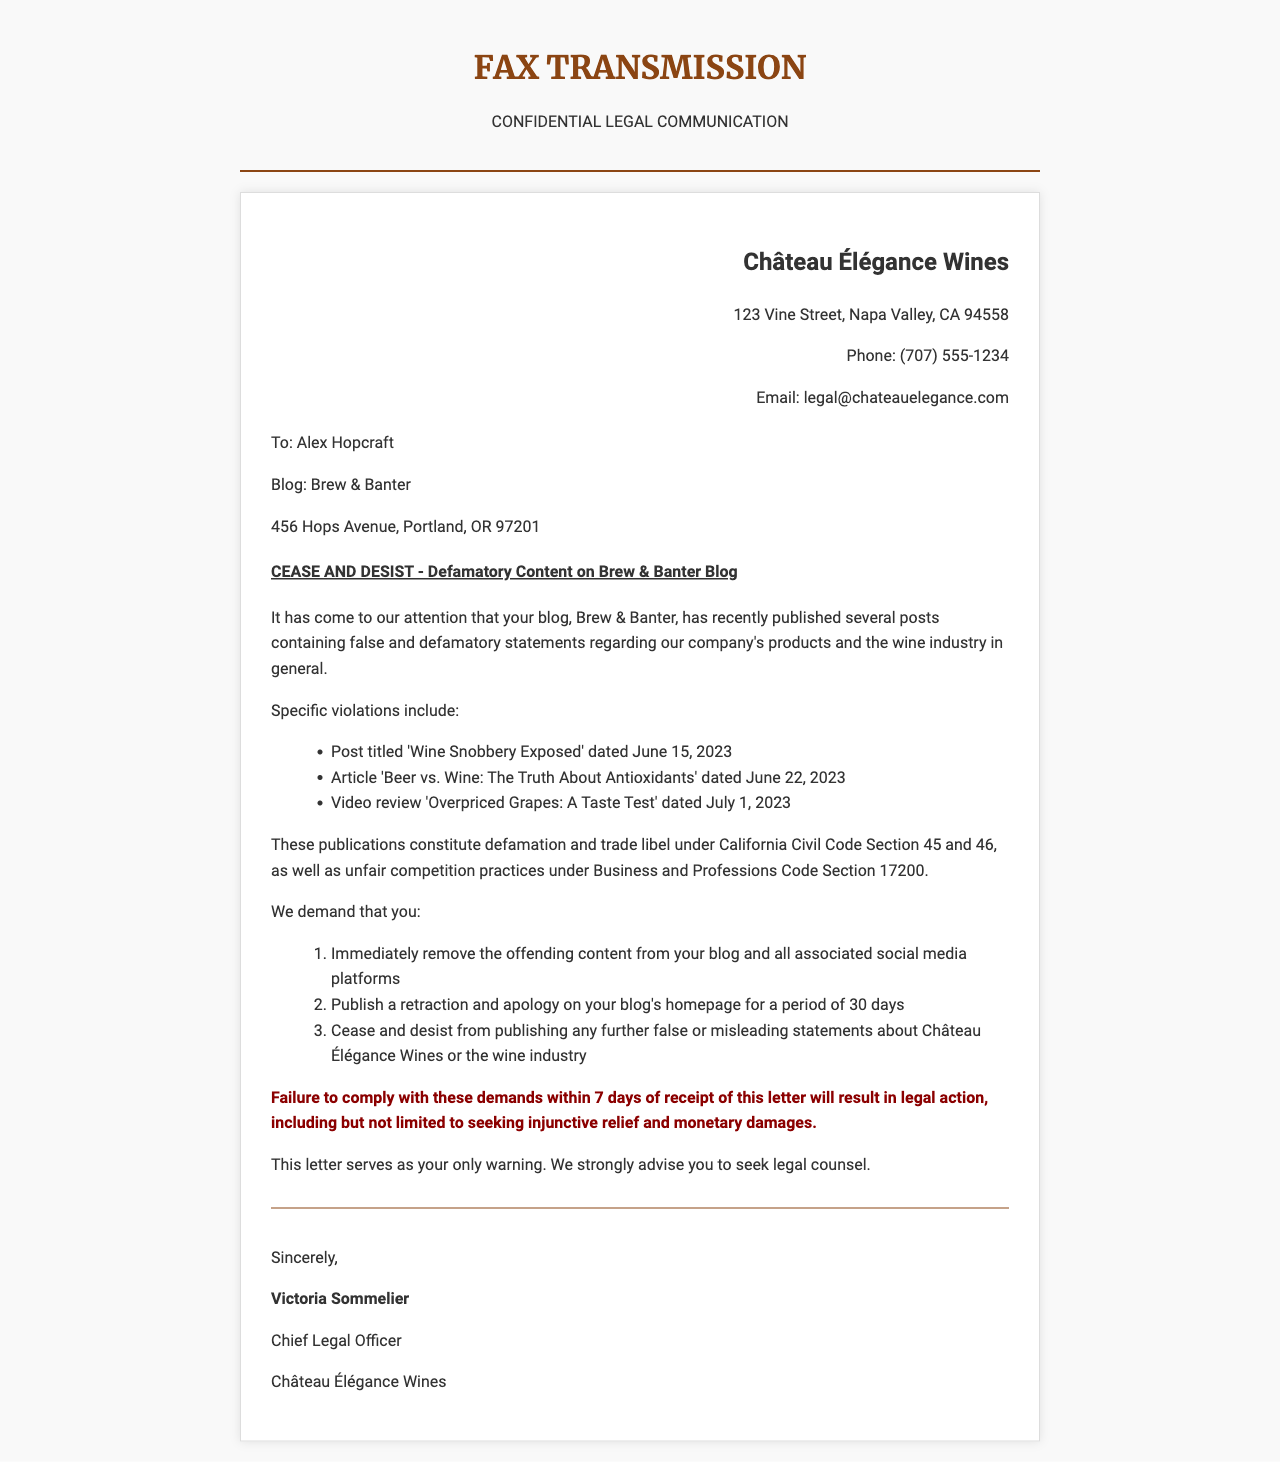What is the name of the wine distributor? The name of the wine distributor is mentioned in the letterhead section of the document.
Answer: Château Élégance Wines Who is the recipient of the cease and desist letter? The recipient's name and blog details are stated in the recipient section of the document.
Answer: Alex Hopcraft What is the date of the first mentioned blog post? The date is provided in the list of specific violations under the content section.
Answer: June 15, 2023 How many demands are made in the letter? The number of demands is detailed in the numbered list under the demands section of the document.
Answer: Three What does the letter classify the blog posts as? The classification of the posts is specified in the content section of the document.
Answer: Defamation and trade libel What is the consequence of failing to comply with the demands? The consequence is mentioned towards the end of the content section.
Answer: Legal action Who signed the letter? The signature section at the end of the document provides the name of the signer.
Answer: Victoria Sommelier What is the subject of the fax? The subject is highlighted prominently in the document's subject section.
Answer: CEASE AND DESIST - Defamatory Content on Brew & Banter Blog How long does the recipient have to comply with the requests? The compliance timeframe is noted in the warning section of the document.
Answer: 7 days 